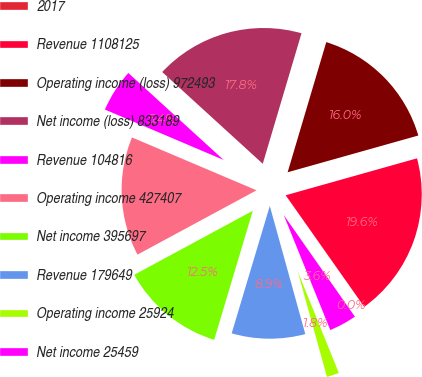Convert chart. <chart><loc_0><loc_0><loc_500><loc_500><pie_chart><fcel>2017<fcel>Revenue 1108125<fcel>Operating income (loss) 972493<fcel>Net income (loss) 833189<fcel>Revenue 104816<fcel>Operating income 427407<fcel>Net income 395697<fcel>Revenue 179649<fcel>Operating income 25924<fcel>Net income 25459<nl><fcel>0.04%<fcel>19.6%<fcel>16.04%<fcel>17.82%<fcel>5.38%<fcel>14.27%<fcel>12.49%<fcel>8.93%<fcel>1.82%<fcel>3.6%<nl></chart> 